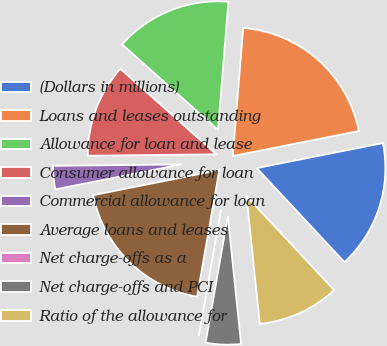<chart> <loc_0><loc_0><loc_500><loc_500><pie_chart><fcel>(Dollars in millions)<fcel>Loans and leases outstanding<fcel>Allowance for loan and lease<fcel>Consumer allowance for loan<fcel>Commercial allowance for loan<fcel>Average loans and leases<fcel>Net charge-offs as a<fcel>Net charge-offs and PCI<fcel>Ratio of the allowance for<nl><fcel>16.18%<fcel>20.59%<fcel>14.71%<fcel>11.76%<fcel>2.94%<fcel>19.12%<fcel>0.0%<fcel>4.41%<fcel>10.29%<nl></chart> 